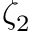Convert formula to latex. <formula><loc_0><loc_0><loc_500><loc_500>\zeta _ { 2 }</formula> 